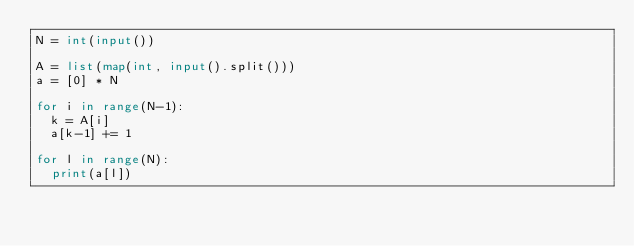Convert code to text. <code><loc_0><loc_0><loc_500><loc_500><_Python_>N = int(input())

A = list(map(int, input().split()))
a = [0] * N

for i in range(N-1):
  k = A[i]
  a[k-1] += 1

for l in range(N):
  print(a[l])
</code> 